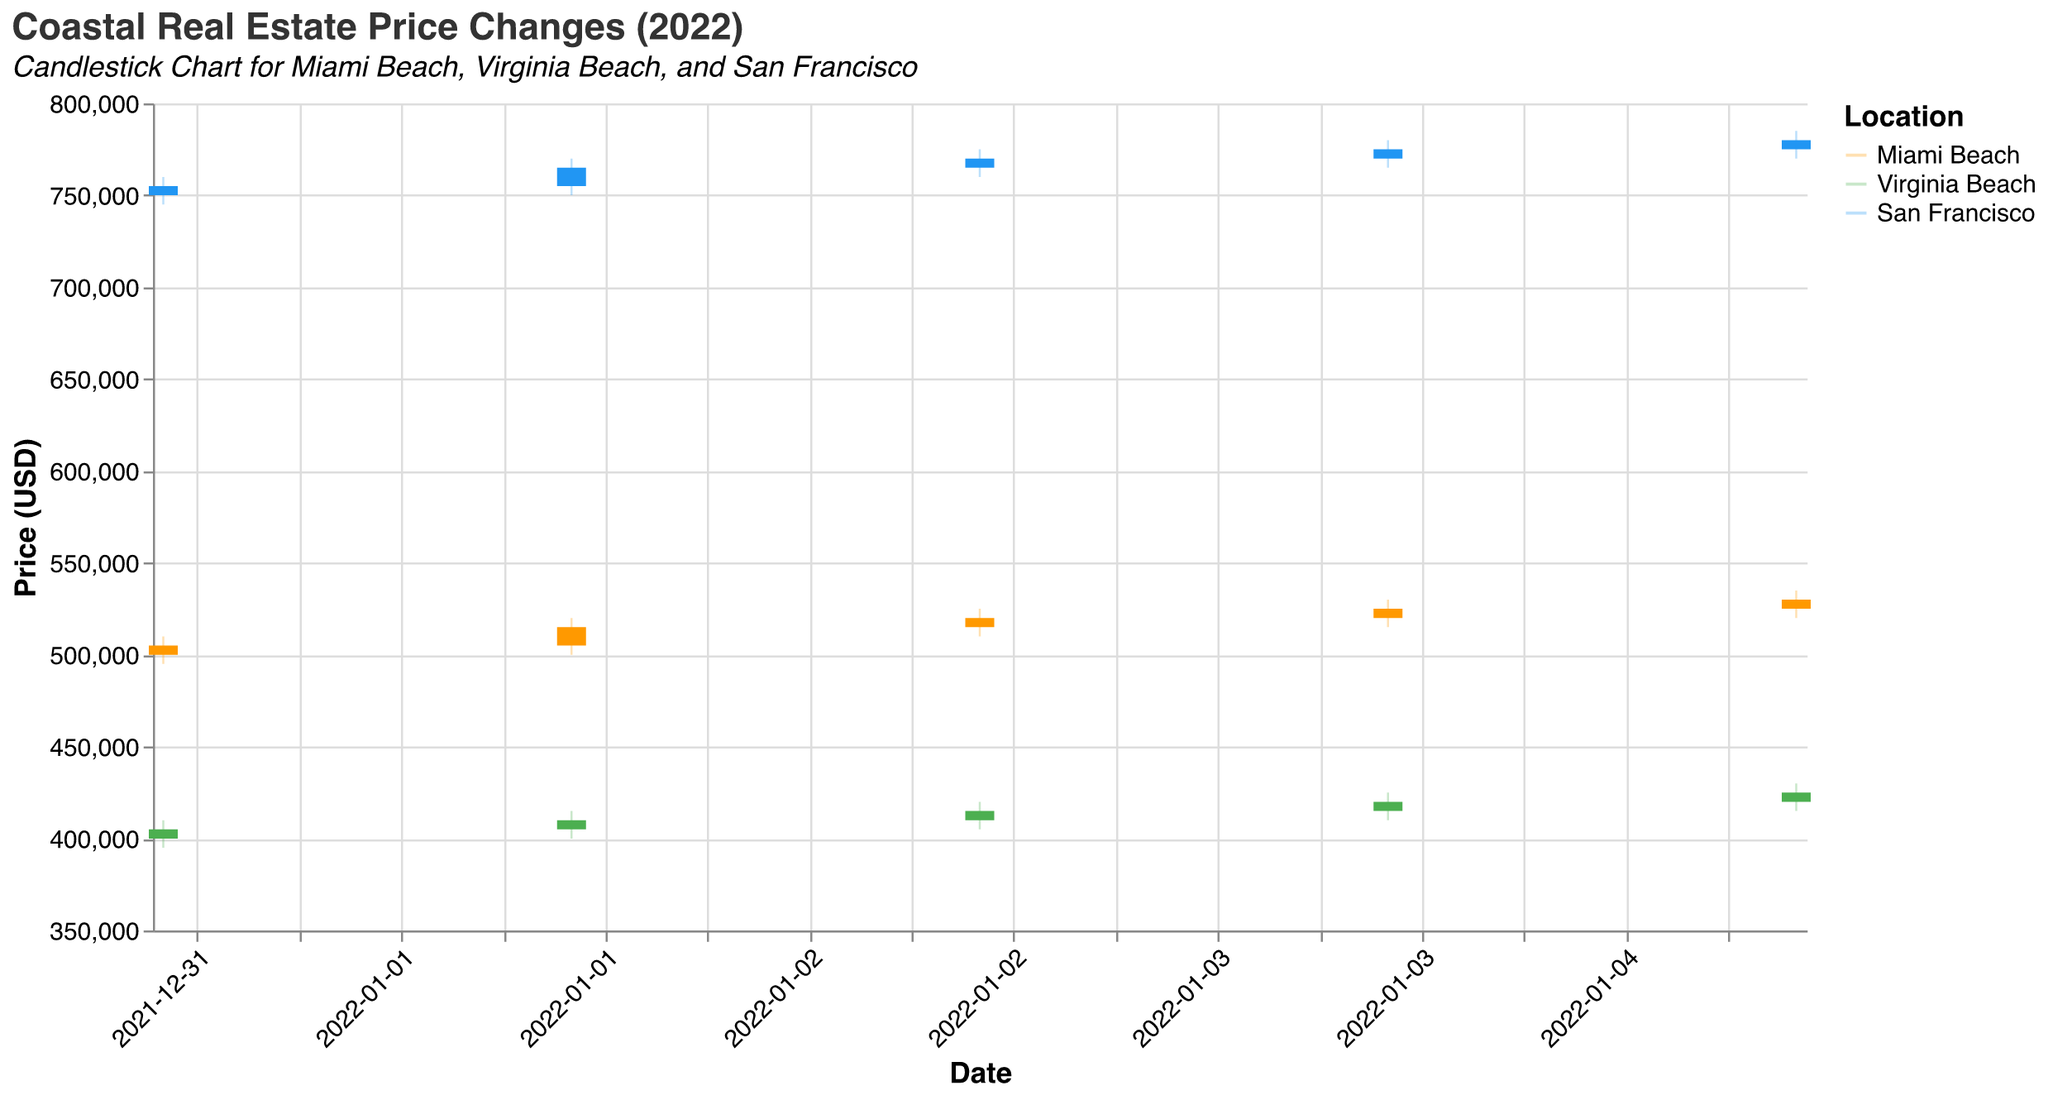What's the title of the figure? The title of the figure is located at the top of the plot and it is specified to provide a quick understanding of the plot's content.
Answer: Coastal Real Estate Price Changes (2022) Which location has the highest closing price on 2022-01-05? To determine this, look at the closing prices for each location on 2022-01-05. Compare these values to see which is the highest.
Answer: San Francisco How does the opening price on 2022-01-03 for Miami Beach compare to Virginia Beach? The opening price for Miami Beach on 2022-01-03 is 515,000 and for Virginia Beach, it is 410,000. Miami Beach's opening price is higher.
Answer: Miami Beach is higher Between 2022-01-01 and 2022-01-05, did any location experience a decrease in closing price? Compare the closing prices for each location from 2022-01-01 to 2022-01-05. If any closing price on 2022-01-05 is lower than on 2022-01-01, then that location experienced a decrease.
Answer: No What’s the trend of San Francisco’s closing prices from 2022-01-01 to 2022-01-05? Observe the closing prices for San Francisco for each date in the given range. Note if the prices are increasing, decreasing, or fluctuating.
Answer: Increasing What is the average closing price for Virginia Beach over the given dates? Add the closing prices for Virginia Beach for each date and divide by the number of dates to find the average. (405000 + 410000 + 415000 + 420000 + 425000) / 5
Answer: 415000 Which location has the largest volume of transactions on 2022-01-03? Check the volume of transactions for each location on 2022-01-03 and compare. The location with the highest value has the largest volume.
Answer: Miami Beach How much did the closing price for Miami Beach increase from 2022-01-01 to 2022-01-05? Subtract the closing price on 2022-01-01 for Miami Beach from the closing price on 2022-01-05. 530000 - 505000
Answer: 25000 What is the lowest low price recorded for San Francisco over the given dates? Examine the low prices recorded for San Francisco on each date. Identify the smallest value among them.
Answer: 745000 Which location saw the smallest range between its high and low prices on 2022-01-03? Calculate the range (high - low) for each location on 2022-01-03, and then compare these ranges to find the smallest one.
Answer: San Francisco 